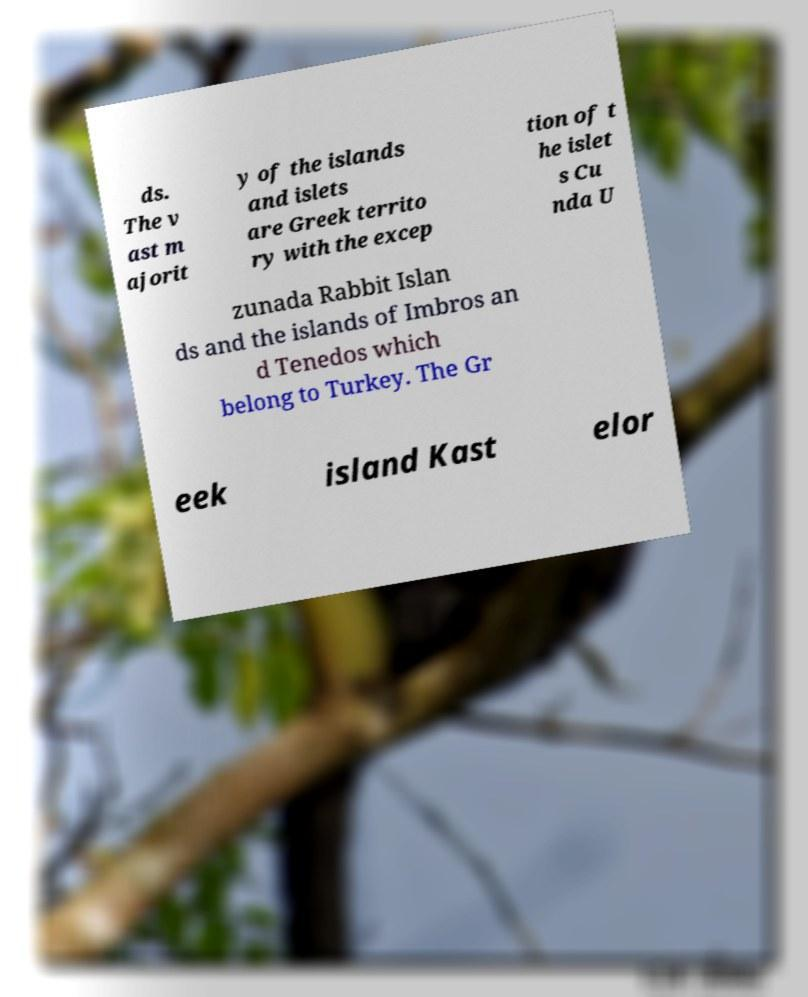What messages or text are displayed in this image? I need them in a readable, typed format. ds. The v ast m ajorit y of the islands and islets are Greek territo ry with the excep tion of t he islet s Cu nda U zunada Rabbit Islan ds and the islands of Imbros an d Tenedos which belong to Turkey. The Gr eek island Kast elor 